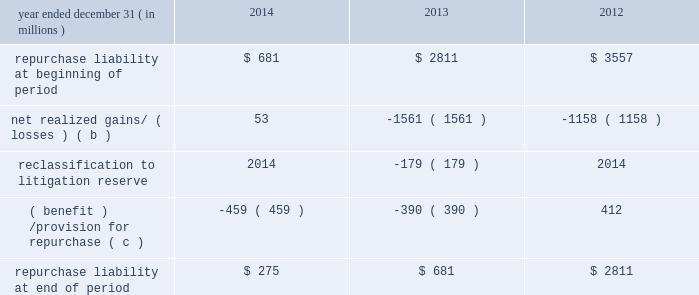Jpmorgan chase & co./2014 annual report 291 therefore , are not recorded on the consolidated balance sheets until settlement date .
The unsettled reverse repurchase agreements and securities borrowing agreements predominantly consist of agreements with regular-way settlement periods .
Loan sales- and securitization-related indemnifications mortgage repurchase liability in connection with the firm 2019s mortgage loan sale and securitization activities with the gses , as described in note 16 , the firm has made representations and warranties that the loans sold meet certain requirements .
The firm has been , and may be , required to repurchase loans and/or indemnify the gses ( e.g. , with 201cmake-whole 201d payments to reimburse the gses for their realized losses on liquidated loans ) .
To the extent that repurchase demands that are received relate to loans that the firm purchased from third parties that remain viable , the firm typically will have the right to seek a recovery of related repurchase losses from the third party .
Generally , the maximum amount of future payments the firm would be required to make for breaches of these representations and warranties would be equal to the unpaid principal balance of such loans that are deemed to have defects that were sold to purchasers ( including securitization-related spes ) plus , in certain circumstances , accrued interest on such loans and certain expense .
The table summarizes the change in the mortgage repurchase liability for each of the periods presented .
Summary of changes in mortgage repurchase liability ( a ) year ended december 31 , ( in millions ) 2014 2013 2012 repurchase liability at beginning of period $ 681 $ 2811 $ 3557 net realized gains/ ( losses ) ( b ) 53 ( 1561 ) ( 1158 ) .
( benefit ) /provision for repurchase ( c ) ( 459 ) ( 390 ) 412 repurchase liability at end of period $ 275 $ 681 $ 2811 ( a ) on october 25 , 2013 , the firm announced that it had reached a $ 1.1 billion agreement with the fhfa to resolve , other than certain limited types of exposures , outstanding and future mortgage repurchase demands associated with loans sold to the gses from 2000 to 2008 .
( b ) presented net of third-party recoveries and included principal losses and accrued interest on repurchased loans , 201cmake-whole 201d settlements , settlements with claimants , and certain related expense .
Make-whole settlements were $ 11 million , $ 414 million and $ 524 million , for the years ended december 31 , 2014 , 2013 and 2012 , respectively .
( c ) included a provision related to new loan sales of $ 4 million , $ 20 million and $ 112 million , for the years ended december 31 , 2014 , 2013 and 2012 , respectively .
Private label securitizations the liability related to repurchase demands associated with private label securitizations is separately evaluated by the firm in establishing its litigation reserves .
On november 15 , 2013 , the firm announced that it had reached a $ 4.5 billion agreement with 21 major institutional investors to make a binding offer to the trustees of 330 residential mortgage-backed securities trusts issued by j.p.morgan , chase , and bear stearns ( 201crmbs trust settlement 201d ) to resolve all representation and warranty claims , as well as all servicing claims , on all trusts issued by j.p .
Morgan , chase , and bear stearns between 2005 and 2008 .
The seven trustees ( or separate and successor trustees ) for this group of 330 trusts have accepted the rmbs trust settlement for 319 trusts in whole or in part and excluded from the settlement 16 trusts in whole or in part .
The trustees 2019 acceptance is subject to a judicial approval proceeding initiated by the trustees , which is pending in new york state court .
In addition , from 2005 to 2008 , washington mutual made certain loan level representations and warranties in connection with approximately $ 165 billion of residential mortgage loans that were originally sold or deposited into private-label securitizations by washington mutual .
Of the $ 165 billion , approximately $ 78 billion has been repaid .
In addition , approximately $ 49 billion of the principal amount of such loans has liquidated with an average loss severity of 59% ( 59 % ) .
Accordingly , the remaining outstanding principal balance of these loans as of december 31 , 2014 , was approximately $ 38 billion , of which $ 8 billion was 60 days or more past due .
The firm believes that any repurchase obligations related to these loans remain with the fdic receivership .
For additional information regarding litigation , see note 31 .
Loans sold with recourse the firm provides servicing for mortgages and certain commercial lending products on both a recourse and nonrecourse basis .
In nonrecourse servicing , the principal credit risk to the firm is the cost of temporary servicing advances of funds ( i.e. , normal servicing advances ) .
In recourse servicing , the servicer agrees to share credit risk with the owner of the mortgage loans , such as fannie mae or freddie mac or a private investor , insurer or guarantor .
Losses on recourse servicing predominantly occur when foreclosure sales proceeds of the property underlying a defaulted loan are less than the sum of the outstanding principal balance , plus accrued interest on the loan and the cost of holding and disposing of the underlying property .
The firm 2019s securitizations are predominantly nonrecourse , thereby effectively transferring the risk of future credit losses to the purchaser of the mortgage-backed securities issued by the trust .
At december 31 , 2014 and 2013 , the unpaid principal balance of loans sold with recourse totaled $ 6.1 billion and $ 7.7 billion , respectively .
The carrying value of the related liability that the firm has recorded , which is representative of the firm 2019s view of the likelihood it .
What were gross realized gains for 2014 without the make whole settlement netting? 
Computations: (53 + 11)
Answer: 64.0. 